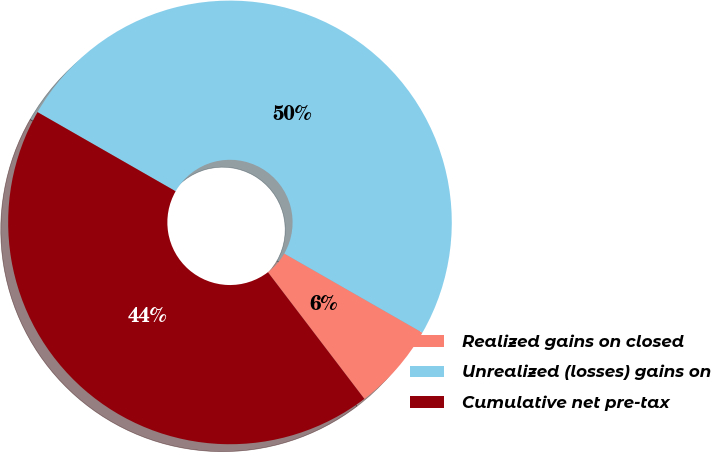Convert chart to OTSL. <chart><loc_0><loc_0><loc_500><loc_500><pie_chart><fcel>Realized gains on closed<fcel>Unrealized (losses) gains on<fcel>Cumulative net pre-tax<nl><fcel>6.36%<fcel>50.0%<fcel>43.64%<nl></chart> 